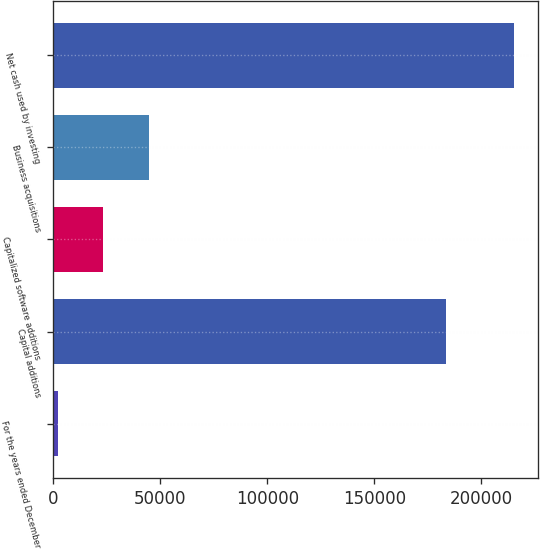Convert chart to OTSL. <chart><loc_0><loc_0><loc_500><loc_500><bar_chart><fcel>For the years ended December<fcel>Capital additions<fcel>Capitalized software additions<fcel>Business acquisitions<fcel>Net cash used by investing<nl><fcel>2006<fcel>183496<fcel>23356.6<fcel>44707.2<fcel>215512<nl></chart> 